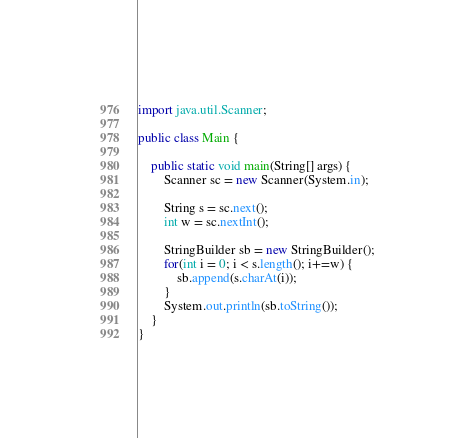Convert code to text. <code><loc_0><loc_0><loc_500><loc_500><_Java_>import java.util.Scanner;
 
public class Main {
 
	public static void main(String[] args) {
		Scanner sc = new Scanner(System.in);
		
		String s = sc.next();
		int w = sc.nextInt();
		
		StringBuilder sb = new StringBuilder();
		for(int i = 0; i < s.length(); i+=w) {
			sb.append(s.charAt(i));
		}
		System.out.println(sb.toString());
	}
}</code> 